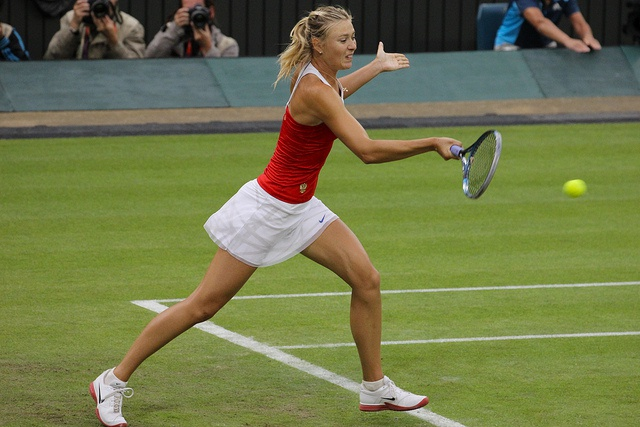Describe the objects in this image and their specific colors. I can see people in black, maroon, gray, and darkgray tones, people in black, gray, and salmon tones, people in black, gray, and maroon tones, people in black, gray, and maroon tones, and tennis racket in black, gray, darkgreen, and olive tones in this image. 